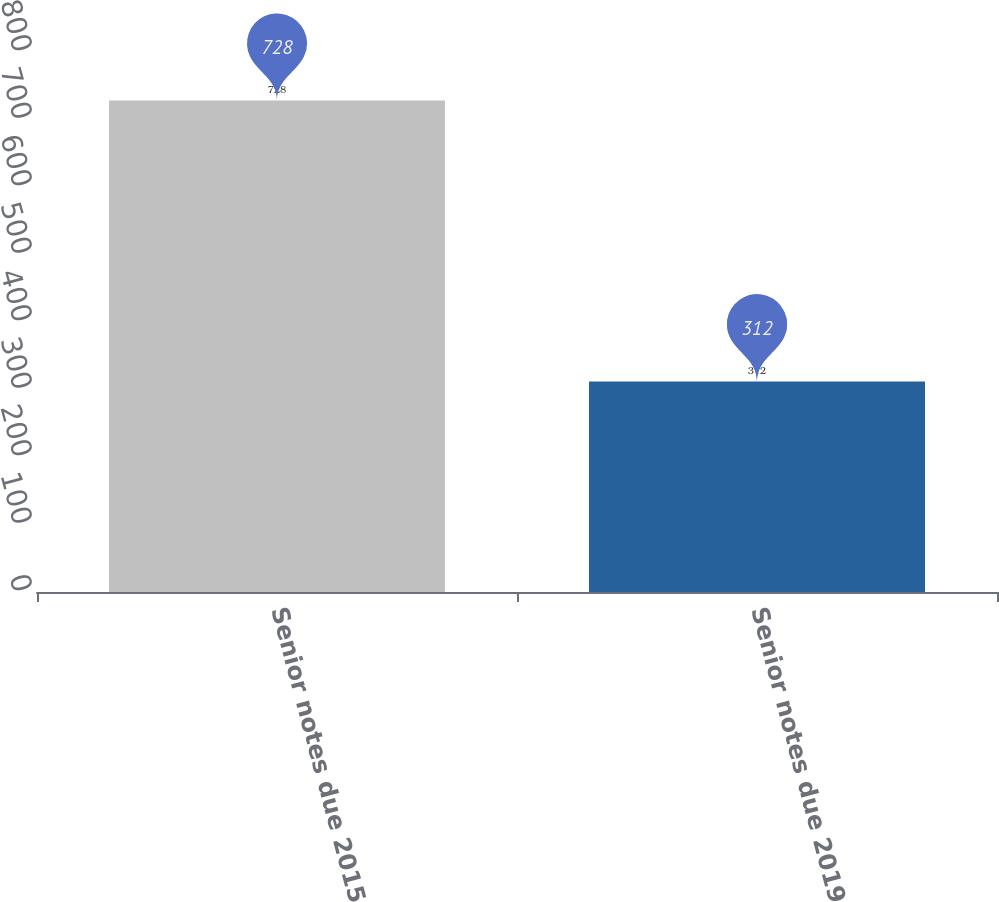Convert chart to OTSL. <chart><loc_0><loc_0><loc_500><loc_500><bar_chart><fcel>Senior notes due 2015<fcel>Senior notes due 2019<nl><fcel>728<fcel>312<nl></chart> 